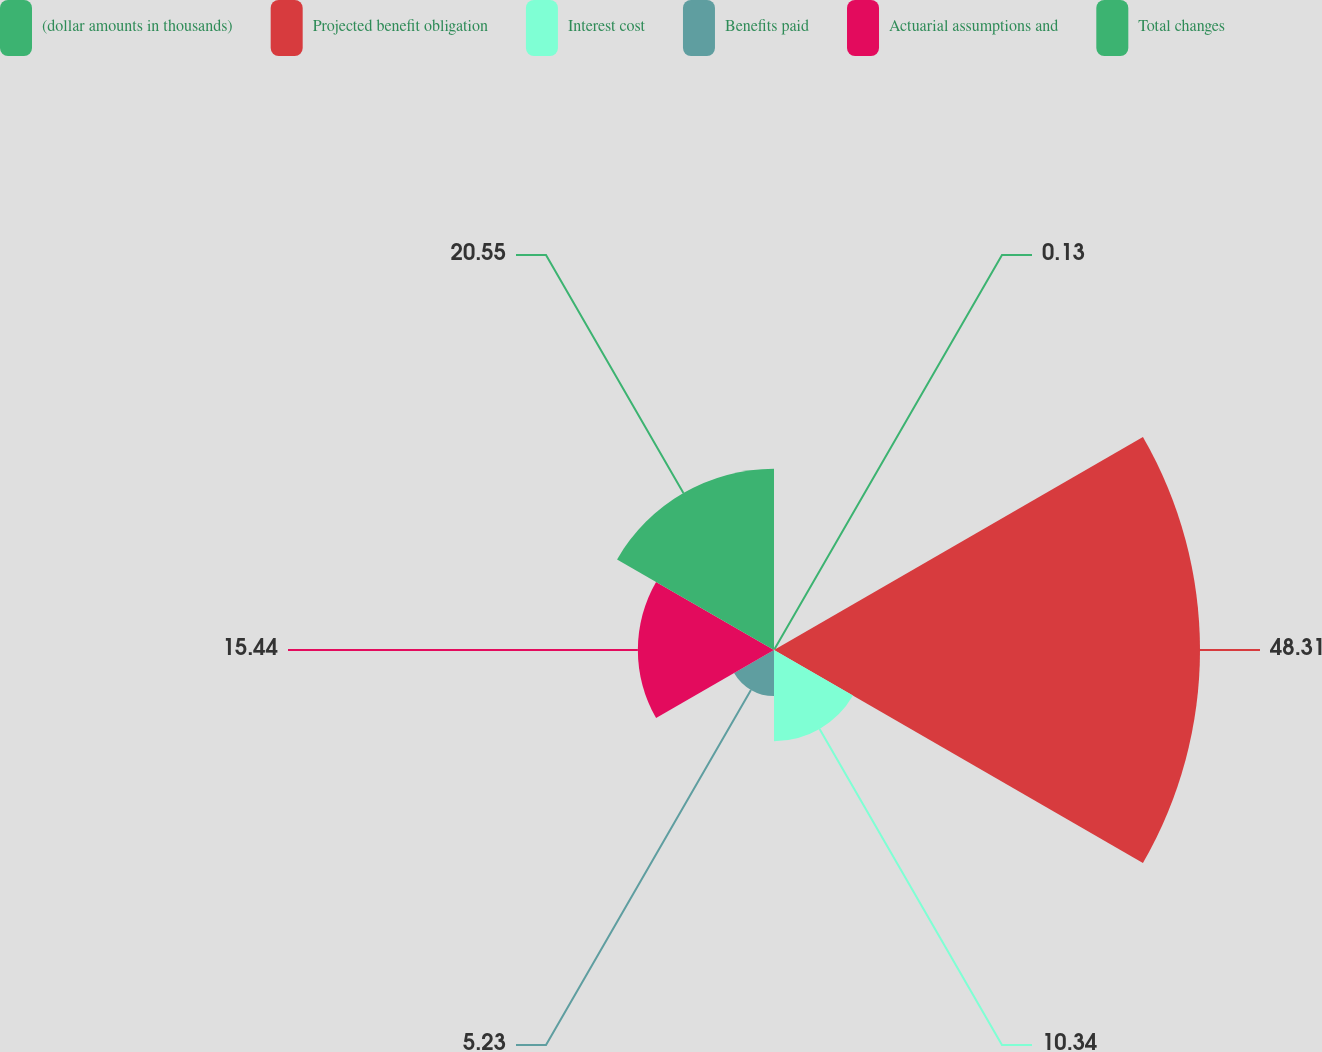Convert chart to OTSL. <chart><loc_0><loc_0><loc_500><loc_500><pie_chart><fcel>(dollar amounts in thousands)<fcel>Projected benefit obligation<fcel>Interest cost<fcel>Benefits paid<fcel>Actuarial assumptions and<fcel>Total changes<nl><fcel>0.13%<fcel>48.31%<fcel>10.34%<fcel>5.23%<fcel>15.44%<fcel>20.55%<nl></chart> 